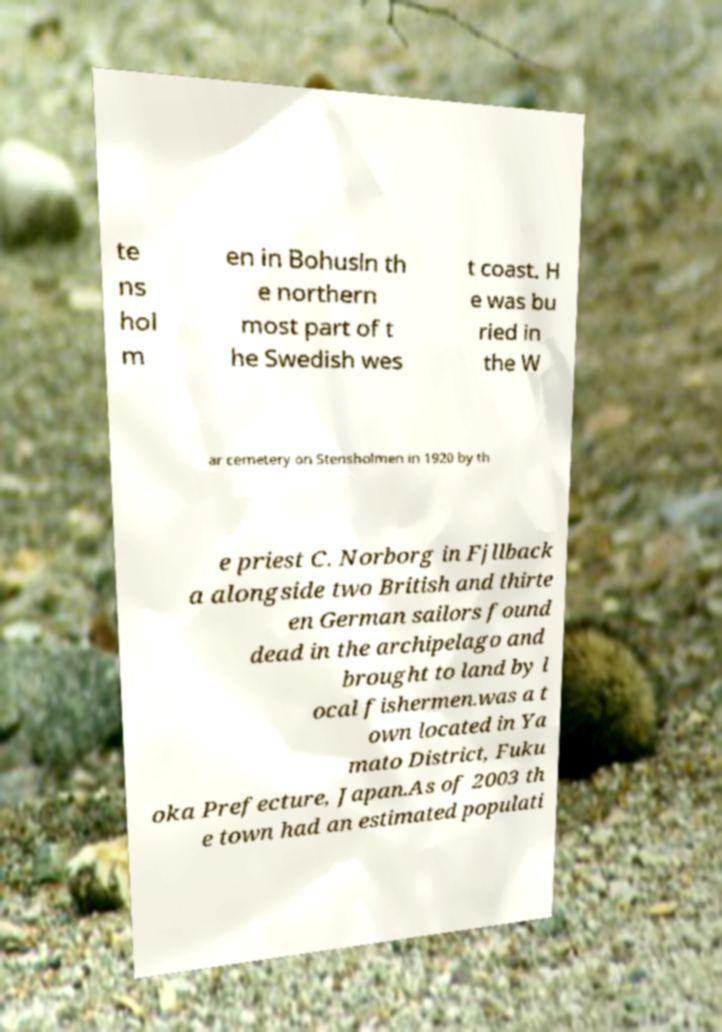There's text embedded in this image that I need extracted. Can you transcribe it verbatim? te ns hol m en in Bohusln th e northern most part of t he Swedish wes t coast. H e was bu ried in the W ar cemetery on Stensholmen in 1920 by th e priest C. Norborg in Fjllback a alongside two British and thirte en German sailors found dead in the archipelago and brought to land by l ocal fishermen.was a t own located in Ya mato District, Fuku oka Prefecture, Japan.As of 2003 th e town had an estimated populati 